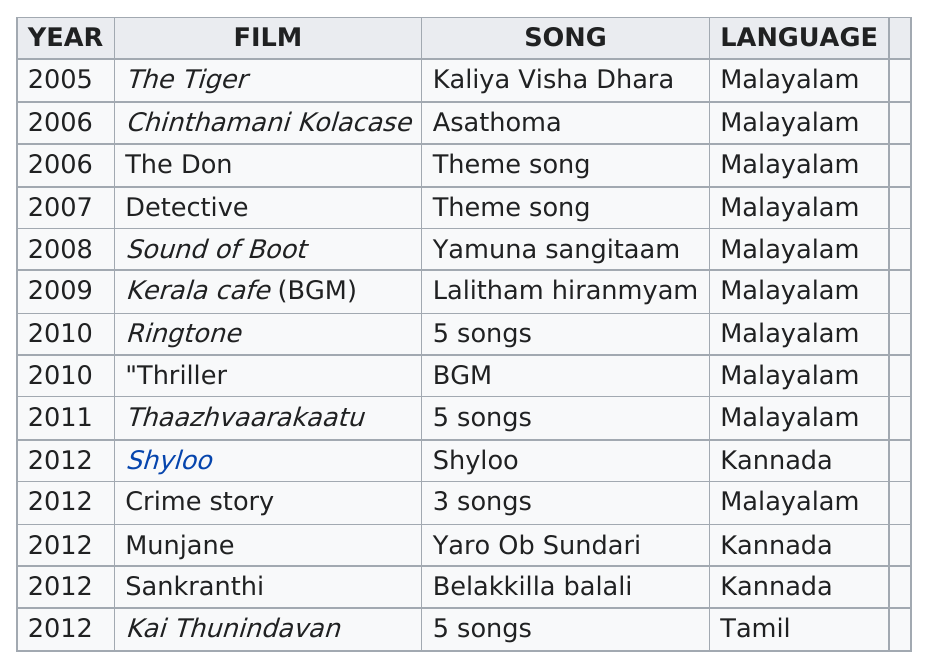Indicate a few pertinent items in this graphic. Ishaan Dev created a total of 5 songs for the movies Kai Thunindavan and Thaazhvaarakaatu. The first Kannada film was "Shyloo. Ishaan Dev provided a total of three songs for movies that were made between 2007 and 2009. Malayalam was the language that was used in the most films. Ishaan Dev has provided music for 14 films. 